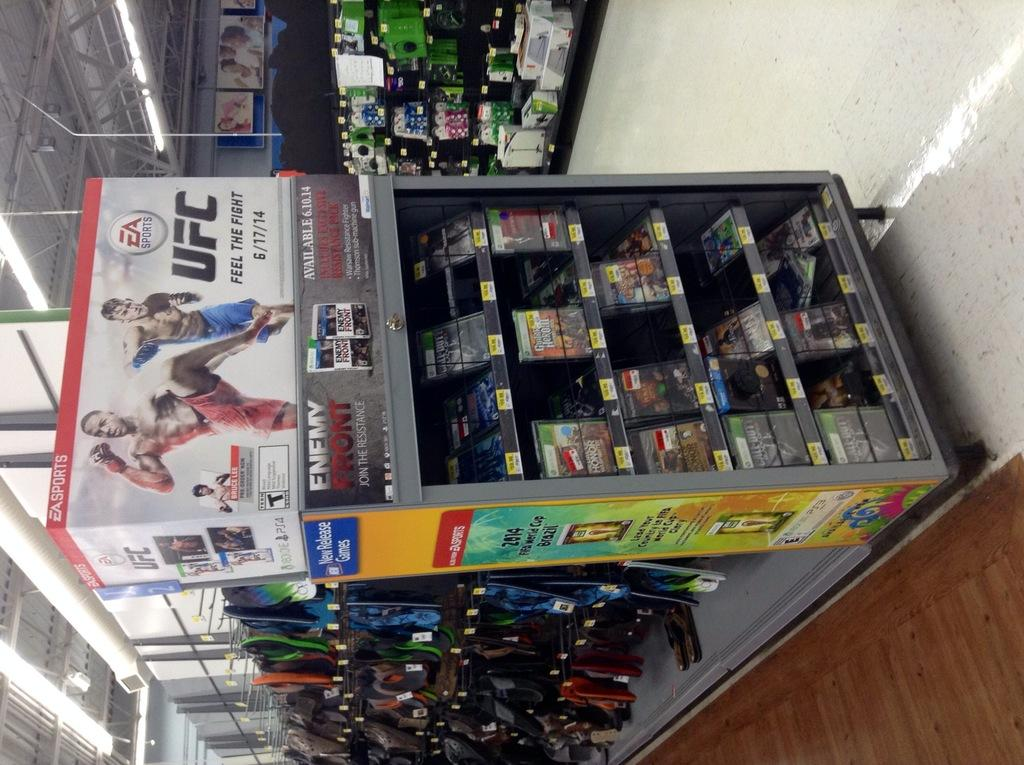<image>
Relay a brief, clear account of the picture shown. A display advertising the game EA sports UFC is on top of a bunch of video games for sale. 